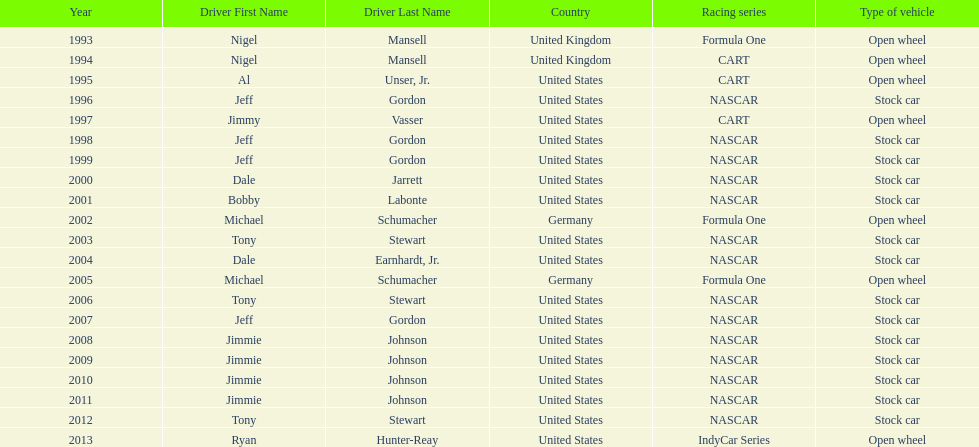Jimmy johnson won how many consecutive espy awards? 4. Would you mind parsing the complete table? {'header': ['Year', 'Driver First Name', 'Driver Last Name', 'Country', 'Racing series', 'Type of vehicle'], 'rows': [['1993', 'Nigel', 'Mansell', 'United Kingdom', 'Formula One', 'Open wheel'], ['1994', 'Nigel', 'Mansell', 'United Kingdom', 'CART', 'Open wheel'], ['1995', 'Al', 'Unser, Jr.', 'United States', 'CART', 'Open wheel'], ['1996', 'Jeff', 'Gordon', 'United States', 'NASCAR', 'Stock car'], ['1997', 'Jimmy', 'Vasser', 'United States', 'CART', 'Open wheel'], ['1998', 'Jeff', 'Gordon', 'United States', 'NASCAR', 'Stock car'], ['1999', 'Jeff', 'Gordon', 'United States', 'NASCAR', 'Stock car'], ['2000', 'Dale', 'Jarrett', 'United States', 'NASCAR', 'Stock car'], ['2001', 'Bobby', 'Labonte', 'United States', 'NASCAR', 'Stock car'], ['2002', 'Michael', 'Schumacher', 'Germany', 'Formula One', 'Open wheel'], ['2003', 'Tony', 'Stewart', 'United States', 'NASCAR', 'Stock car'], ['2004', 'Dale', 'Earnhardt, Jr.', 'United States', 'NASCAR', 'Stock car'], ['2005', 'Michael', 'Schumacher', 'Germany', 'Formula One', 'Open wheel'], ['2006', 'Tony', 'Stewart', 'United States', 'NASCAR', 'Stock car'], ['2007', 'Jeff', 'Gordon', 'United States', 'NASCAR', 'Stock car'], ['2008', 'Jimmie', 'Johnson', 'United States', 'NASCAR', 'Stock car'], ['2009', 'Jimmie', 'Johnson', 'United States', 'NASCAR', 'Stock car'], ['2010', 'Jimmie', 'Johnson', 'United States', 'NASCAR', 'Stock car'], ['2011', 'Jimmie', 'Johnson', 'United States', 'NASCAR', 'Stock car'], ['2012', 'Tony', 'Stewart', 'United States', 'NASCAR', 'Stock car'], ['2013', 'Ryan', 'Hunter-Reay', 'United States', 'IndyCar Series', 'Open wheel']]} 